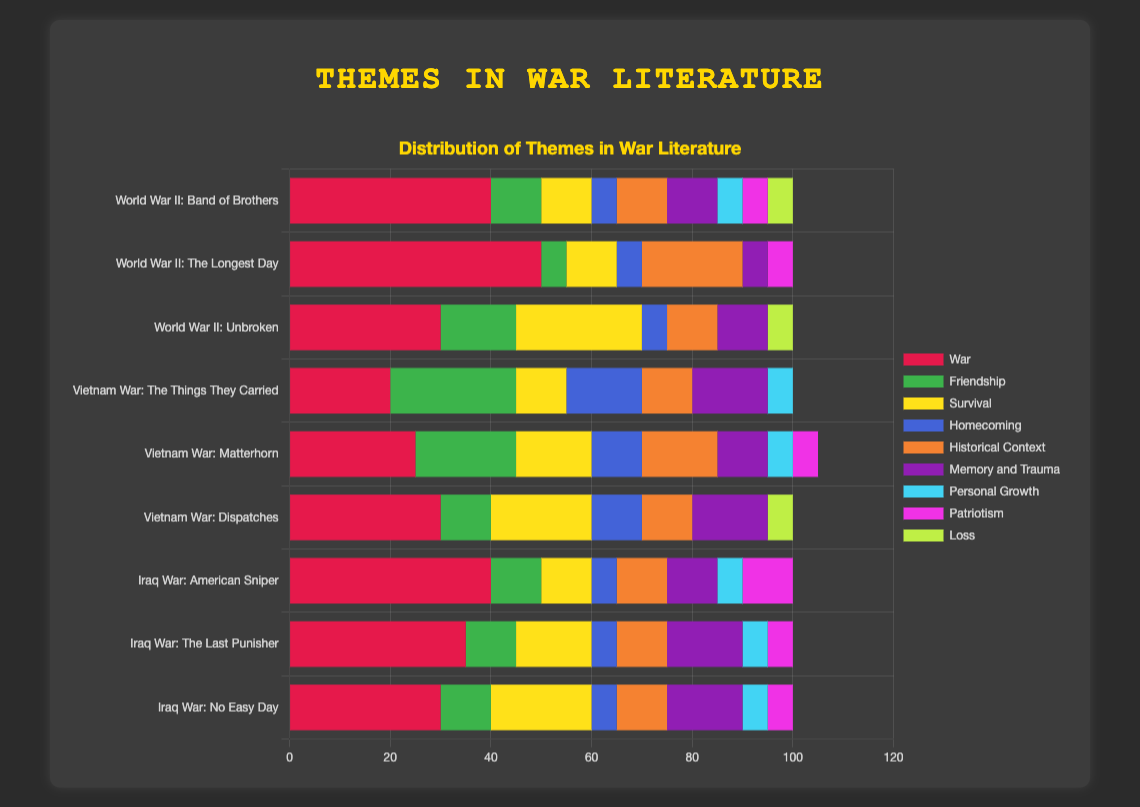Which book from the World War II group emphasizes the theme of "War" the most? Identify the sections representing the "War" theme in books from the World War II group. The longest bar will indicate the highest percentage. "The Longest Day" has a 50% emphasis on "War."
Answer: "The Longest Day" Between "The Things They Carried" and "Dispatches," which book from the Vietnam War group focuses more on "Memory and Trauma"? Compare the bars labeled "Memory and Trauma". "The Things They Carried" and "Dispatches" have the same emphasis on "Memory and Trauma" of 15%.
Answer: Equal focus Which war group has the book with the highest percentage emphasis on the theme of "Friendship"? Compare the bars for all books across all war groups focusing on "Friendship." The highest is "The Things They Carried" with 25% from the Vietnam War group.
Answer: Vietnam War What is the total percentage of the "Patriotism" theme in the Iraq War books? Sum the "Patriotism" percentages for all Iraq War books: 10% ("American Sniper") + 5% ("The Last Punisher") + 5% ("No Easy Day").
Answer: 20% Which war group's books have the highest average percentage of the "Survival" theme? Calculate the average "Survival" percentage for books in each war group.
Answer: Iraq War How does the "Historical Context" theme percentage in "The Longest Day" compare to "Unbroken"? Subtract the "Historical Context" percentages: 20% ("The Longest Day") - 10% ("Unbroken").
Answer: 10% higher in "The Longest Day" In terms of "Personal Growth," which book has the least emphasis among all war groups? Identify the smallest "Personal Growth" percentage among all books. It is "The Longest Day" with 0%.
Answer: "The Longest Day" What is the combined percentage of "War" and "Survival" themes in "Unbroken"? Sum the "War" and "Survival" percentages for "Unbroken": 30% (War) + 25% (Survival).
Answer: 55% Does any book have an equal percentage emphasis on both "Homecoming" and "Patriotism"? If so, name it. Check for equal "Homecoming" and "Patriotism" percentages across all books. No book matches this criterion.
Answer: None 